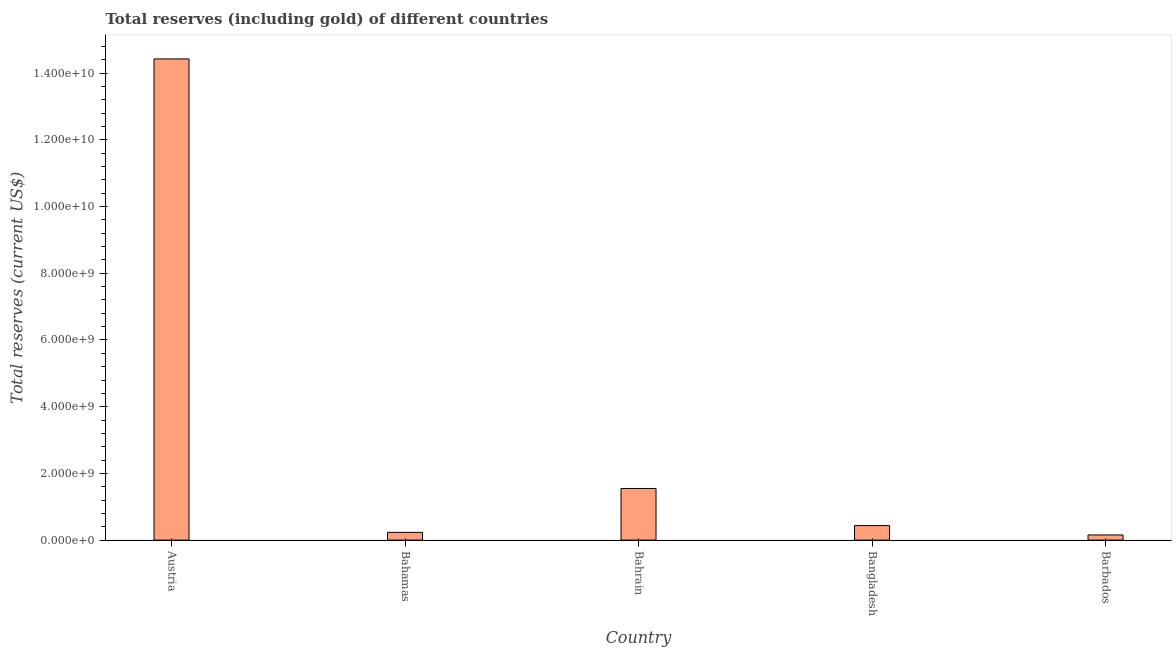Does the graph contain any zero values?
Provide a succinct answer. No. What is the title of the graph?
Provide a short and direct response. Total reserves (including gold) of different countries. What is the label or title of the Y-axis?
Offer a very short reply. Total reserves (current US$). What is the total reserves (including gold) in Austria?
Give a very brief answer. 1.44e+1. Across all countries, what is the maximum total reserves (including gold)?
Offer a very short reply. 1.44e+1. Across all countries, what is the minimum total reserves (including gold)?
Ensure brevity in your answer.  1.54e+08. In which country was the total reserves (including gold) maximum?
Keep it short and to the point. Austria. In which country was the total reserves (including gold) minimum?
Your answer should be compact. Barbados. What is the sum of the total reserves (including gold)?
Your answer should be compact. 1.68e+1. What is the difference between the total reserves (including gold) in Austria and Bangladesh?
Give a very brief answer. 1.40e+1. What is the average total reserves (including gold) per country?
Give a very brief answer. 3.36e+09. What is the median total reserves (including gold)?
Ensure brevity in your answer.  4.35e+08. In how many countries, is the total reserves (including gold) greater than 9600000000 US$?
Your answer should be compact. 1. What is the ratio of the total reserves (including gold) in Bahamas to that in Bangladesh?
Make the answer very short. 0.53. What is the difference between the highest and the second highest total reserves (including gold)?
Keep it short and to the point. 1.29e+1. Is the sum of the total reserves (including gold) in Bahrain and Barbados greater than the maximum total reserves (including gold) across all countries?
Ensure brevity in your answer.  No. What is the difference between the highest and the lowest total reserves (including gold)?
Provide a short and direct response. 1.43e+1. In how many countries, is the total reserves (including gold) greater than the average total reserves (including gold) taken over all countries?
Your response must be concise. 1. How many bars are there?
Your response must be concise. 5. Are all the bars in the graph horizontal?
Your answer should be compact. No. What is the difference between two consecutive major ticks on the Y-axis?
Your answer should be compact. 2.00e+09. Are the values on the major ticks of Y-axis written in scientific E-notation?
Keep it short and to the point. Yes. What is the Total reserves (current US$) in Austria?
Give a very brief answer. 1.44e+1. What is the Total reserves (current US$) in Bahamas?
Provide a succinct answer. 2.31e+08. What is the Total reserves (current US$) of Bahrain?
Ensure brevity in your answer.  1.55e+09. What is the Total reserves (current US$) in Bangladesh?
Your answer should be compact. 4.35e+08. What is the Total reserves (current US$) in Barbados?
Ensure brevity in your answer.  1.54e+08. What is the difference between the Total reserves (current US$) in Austria and Bahamas?
Offer a terse response. 1.42e+1. What is the difference between the Total reserves (current US$) in Austria and Bahrain?
Provide a short and direct response. 1.29e+1. What is the difference between the Total reserves (current US$) in Austria and Bangladesh?
Your answer should be very brief. 1.40e+1. What is the difference between the Total reserves (current US$) in Austria and Barbados?
Give a very brief answer. 1.43e+1. What is the difference between the Total reserves (current US$) in Bahamas and Bahrain?
Offer a very short reply. -1.32e+09. What is the difference between the Total reserves (current US$) in Bahamas and Bangladesh?
Provide a short and direct response. -2.03e+08. What is the difference between the Total reserves (current US$) in Bahamas and Barbados?
Your answer should be compact. 7.74e+07. What is the difference between the Total reserves (current US$) in Bahrain and Bangladesh?
Provide a succinct answer. 1.11e+09. What is the difference between the Total reserves (current US$) in Bahrain and Barbados?
Make the answer very short. 1.39e+09. What is the difference between the Total reserves (current US$) in Bangladesh and Barbados?
Provide a short and direct response. 2.81e+08. What is the ratio of the Total reserves (current US$) in Austria to that in Bahamas?
Your answer should be very brief. 62.32. What is the ratio of the Total reserves (current US$) in Austria to that in Bahrain?
Make the answer very short. 9.32. What is the ratio of the Total reserves (current US$) in Austria to that in Bangladesh?
Make the answer very short. 33.18. What is the ratio of the Total reserves (current US$) in Austria to that in Barbados?
Provide a succinct answer. 93.63. What is the ratio of the Total reserves (current US$) in Bahamas to that in Bangladesh?
Your answer should be very brief. 0.53. What is the ratio of the Total reserves (current US$) in Bahamas to that in Barbados?
Your answer should be very brief. 1.5. What is the ratio of the Total reserves (current US$) in Bahrain to that in Bangladesh?
Ensure brevity in your answer.  3.56. What is the ratio of the Total reserves (current US$) in Bahrain to that in Barbados?
Make the answer very short. 10.05. What is the ratio of the Total reserves (current US$) in Bangladesh to that in Barbados?
Provide a short and direct response. 2.82. 